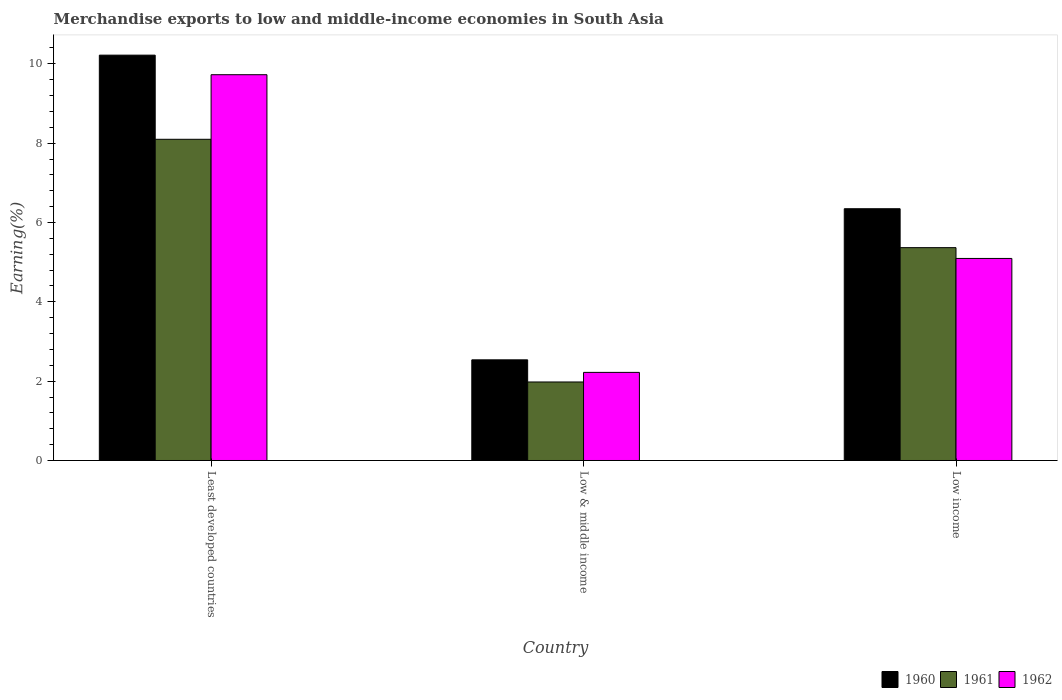How many different coloured bars are there?
Make the answer very short. 3. How many groups of bars are there?
Make the answer very short. 3. Are the number of bars per tick equal to the number of legend labels?
Offer a very short reply. Yes. How many bars are there on the 3rd tick from the left?
Make the answer very short. 3. How many bars are there on the 1st tick from the right?
Give a very brief answer. 3. What is the label of the 2nd group of bars from the left?
Your answer should be compact. Low & middle income. What is the percentage of amount earned from merchandise exports in 1960 in Low income?
Keep it short and to the point. 6.35. Across all countries, what is the maximum percentage of amount earned from merchandise exports in 1960?
Provide a short and direct response. 10.22. Across all countries, what is the minimum percentage of amount earned from merchandise exports in 1961?
Ensure brevity in your answer.  1.98. In which country was the percentage of amount earned from merchandise exports in 1962 maximum?
Provide a short and direct response. Least developed countries. In which country was the percentage of amount earned from merchandise exports in 1961 minimum?
Make the answer very short. Low & middle income. What is the total percentage of amount earned from merchandise exports in 1960 in the graph?
Give a very brief answer. 19.1. What is the difference between the percentage of amount earned from merchandise exports in 1961 in Least developed countries and that in Low & middle income?
Your answer should be very brief. 6.12. What is the difference between the percentage of amount earned from merchandise exports in 1961 in Low income and the percentage of amount earned from merchandise exports in 1960 in Low & middle income?
Offer a terse response. 2.83. What is the average percentage of amount earned from merchandise exports in 1961 per country?
Your answer should be very brief. 5.15. What is the difference between the percentage of amount earned from merchandise exports of/in 1960 and percentage of amount earned from merchandise exports of/in 1961 in Low & middle income?
Provide a short and direct response. 0.56. In how many countries, is the percentage of amount earned from merchandise exports in 1960 greater than 3.2 %?
Your response must be concise. 2. What is the ratio of the percentage of amount earned from merchandise exports in 1962 in Low & middle income to that in Low income?
Offer a terse response. 0.44. What is the difference between the highest and the second highest percentage of amount earned from merchandise exports in 1962?
Your answer should be compact. 7.5. What is the difference between the highest and the lowest percentage of amount earned from merchandise exports in 1962?
Offer a very short reply. 7.5. In how many countries, is the percentage of amount earned from merchandise exports in 1962 greater than the average percentage of amount earned from merchandise exports in 1962 taken over all countries?
Provide a succinct answer. 1. What does the 1st bar from the left in Least developed countries represents?
Your answer should be very brief. 1960. How many bars are there?
Give a very brief answer. 9. Are all the bars in the graph horizontal?
Provide a short and direct response. No. What is the difference between two consecutive major ticks on the Y-axis?
Provide a short and direct response. 2. Are the values on the major ticks of Y-axis written in scientific E-notation?
Make the answer very short. No. Does the graph contain grids?
Ensure brevity in your answer.  No. Where does the legend appear in the graph?
Your response must be concise. Bottom right. What is the title of the graph?
Ensure brevity in your answer.  Merchandise exports to low and middle-income economies in South Asia. Does "2004" appear as one of the legend labels in the graph?
Offer a very short reply. No. What is the label or title of the X-axis?
Ensure brevity in your answer.  Country. What is the label or title of the Y-axis?
Keep it short and to the point. Earning(%). What is the Earning(%) of 1960 in Least developed countries?
Provide a succinct answer. 10.22. What is the Earning(%) in 1961 in Least developed countries?
Keep it short and to the point. 8.1. What is the Earning(%) of 1962 in Least developed countries?
Your response must be concise. 9.73. What is the Earning(%) of 1960 in Low & middle income?
Ensure brevity in your answer.  2.54. What is the Earning(%) in 1961 in Low & middle income?
Give a very brief answer. 1.98. What is the Earning(%) in 1962 in Low & middle income?
Provide a succinct answer. 2.22. What is the Earning(%) in 1960 in Low income?
Keep it short and to the point. 6.35. What is the Earning(%) of 1961 in Low income?
Offer a very short reply. 5.37. What is the Earning(%) in 1962 in Low income?
Your response must be concise. 5.09. Across all countries, what is the maximum Earning(%) of 1960?
Provide a succinct answer. 10.22. Across all countries, what is the maximum Earning(%) in 1961?
Offer a very short reply. 8.1. Across all countries, what is the maximum Earning(%) in 1962?
Make the answer very short. 9.73. Across all countries, what is the minimum Earning(%) of 1960?
Make the answer very short. 2.54. Across all countries, what is the minimum Earning(%) of 1961?
Your response must be concise. 1.98. Across all countries, what is the minimum Earning(%) of 1962?
Make the answer very short. 2.22. What is the total Earning(%) of 1960 in the graph?
Make the answer very short. 19.1. What is the total Earning(%) of 1961 in the graph?
Provide a succinct answer. 15.44. What is the total Earning(%) in 1962 in the graph?
Give a very brief answer. 17.04. What is the difference between the Earning(%) of 1960 in Least developed countries and that in Low & middle income?
Offer a terse response. 7.68. What is the difference between the Earning(%) of 1961 in Least developed countries and that in Low & middle income?
Your answer should be compact. 6.12. What is the difference between the Earning(%) of 1962 in Least developed countries and that in Low & middle income?
Provide a succinct answer. 7.5. What is the difference between the Earning(%) of 1960 in Least developed countries and that in Low income?
Offer a very short reply. 3.87. What is the difference between the Earning(%) in 1961 in Least developed countries and that in Low income?
Your answer should be very brief. 2.73. What is the difference between the Earning(%) in 1962 in Least developed countries and that in Low income?
Give a very brief answer. 4.63. What is the difference between the Earning(%) of 1960 in Low & middle income and that in Low income?
Give a very brief answer. -3.81. What is the difference between the Earning(%) of 1961 in Low & middle income and that in Low income?
Provide a succinct answer. -3.39. What is the difference between the Earning(%) in 1962 in Low & middle income and that in Low income?
Keep it short and to the point. -2.87. What is the difference between the Earning(%) of 1960 in Least developed countries and the Earning(%) of 1961 in Low & middle income?
Your answer should be very brief. 8.24. What is the difference between the Earning(%) in 1960 in Least developed countries and the Earning(%) in 1962 in Low & middle income?
Your response must be concise. 8. What is the difference between the Earning(%) in 1961 in Least developed countries and the Earning(%) in 1962 in Low & middle income?
Your answer should be very brief. 5.88. What is the difference between the Earning(%) of 1960 in Least developed countries and the Earning(%) of 1961 in Low income?
Provide a short and direct response. 4.85. What is the difference between the Earning(%) of 1960 in Least developed countries and the Earning(%) of 1962 in Low income?
Offer a terse response. 5.13. What is the difference between the Earning(%) of 1961 in Least developed countries and the Earning(%) of 1962 in Low income?
Offer a terse response. 3. What is the difference between the Earning(%) of 1960 in Low & middle income and the Earning(%) of 1961 in Low income?
Keep it short and to the point. -2.83. What is the difference between the Earning(%) in 1960 in Low & middle income and the Earning(%) in 1962 in Low income?
Your response must be concise. -2.56. What is the difference between the Earning(%) in 1961 in Low & middle income and the Earning(%) in 1962 in Low income?
Provide a short and direct response. -3.11. What is the average Earning(%) in 1960 per country?
Provide a short and direct response. 6.37. What is the average Earning(%) in 1961 per country?
Give a very brief answer. 5.15. What is the average Earning(%) in 1962 per country?
Offer a very short reply. 5.68. What is the difference between the Earning(%) in 1960 and Earning(%) in 1961 in Least developed countries?
Make the answer very short. 2.12. What is the difference between the Earning(%) in 1960 and Earning(%) in 1962 in Least developed countries?
Offer a terse response. 0.49. What is the difference between the Earning(%) in 1961 and Earning(%) in 1962 in Least developed countries?
Offer a terse response. -1.63. What is the difference between the Earning(%) of 1960 and Earning(%) of 1961 in Low & middle income?
Offer a terse response. 0.56. What is the difference between the Earning(%) in 1960 and Earning(%) in 1962 in Low & middle income?
Keep it short and to the point. 0.32. What is the difference between the Earning(%) of 1961 and Earning(%) of 1962 in Low & middle income?
Keep it short and to the point. -0.24. What is the difference between the Earning(%) of 1960 and Earning(%) of 1961 in Low income?
Offer a very short reply. 0.98. What is the difference between the Earning(%) of 1960 and Earning(%) of 1962 in Low income?
Your answer should be compact. 1.25. What is the difference between the Earning(%) in 1961 and Earning(%) in 1962 in Low income?
Offer a very short reply. 0.27. What is the ratio of the Earning(%) of 1960 in Least developed countries to that in Low & middle income?
Your answer should be compact. 4.03. What is the ratio of the Earning(%) in 1961 in Least developed countries to that in Low & middle income?
Provide a short and direct response. 4.09. What is the ratio of the Earning(%) of 1962 in Least developed countries to that in Low & middle income?
Make the answer very short. 4.38. What is the ratio of the Earning(%) in 1960 in Least developed countries to that in Low income?
Your answer should be compact. 1.61. What is the ratio of the Earning(%) in 1961 in Least developed countries to that in Low income?
Provide a succinct answer. 1.51. What is the ratio of the Earning(%) of 1962 in Least developed countries to that in Low income?
Offer a terse response. 1.91. What is the ratio of the Earning(%) in 1960 in Low & middle income to that in Low income?
Give a very brief answer. 0.4. What is the ratio of the Earning(%) of 1961 in Low & middle income to that in Low income?
Provide a succinct answer. 0.37. What is the ratio of the Earning(%) of 1962 in Low & middle income to that in Low income?
Make the answer very short. 0.44. What is the difference between the highest and the second highest Earning(%) in 1960?
Make the answer very short. 3.87. What is the difference between the highest and the second highest Earning(%) of 1961?
Offer a very short reply. 2.73. What is the difference between the highest and the second highest Earning(%) in 1962?
Offer a very short reply. 4.63. What is the difference between the highest and the lowest Earning(%) in 1960?
Make the answer very short. 7.68. What is the difference between the highest and the lowest Earning(%) of 1961?
Ensure brevity in your answer.  6.12. What is the difference between the highest and the lowest Earning(%) in 1962?
Your response must be concise. 7.5. 